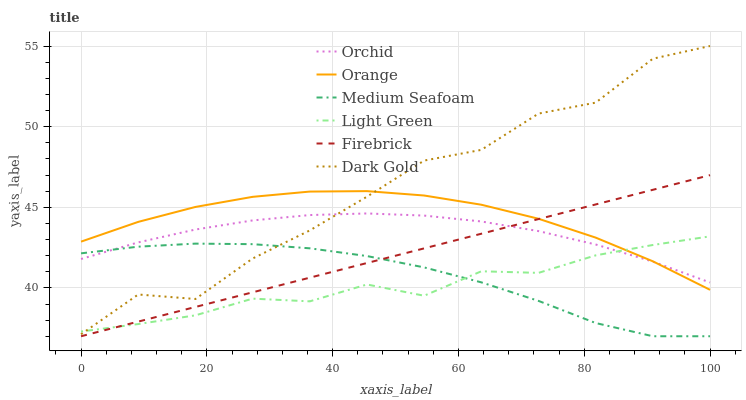Does Firebrick have the minimum area under the curve?
Answer yes or no. No. Does Firebrick have the maximum area under the curve?
Answer yes or no. No. Is Light Green the smoothest?
Answer yes or no. No. Is Light Green the roughest?
Answer yes or no. No. Does Light Green have the lowest value?
Answer yes or no. No. Does Firebrick have the highest value?
Answer yes or no. No. Is Firebrick less than Dark Gold?
Answer yes or no. Yes. Is Orange greater than Medium Seafoam?
Answer yes or no. Yes. Does Firebrick intersect Dark Gold?
Answer yes or no. No. 